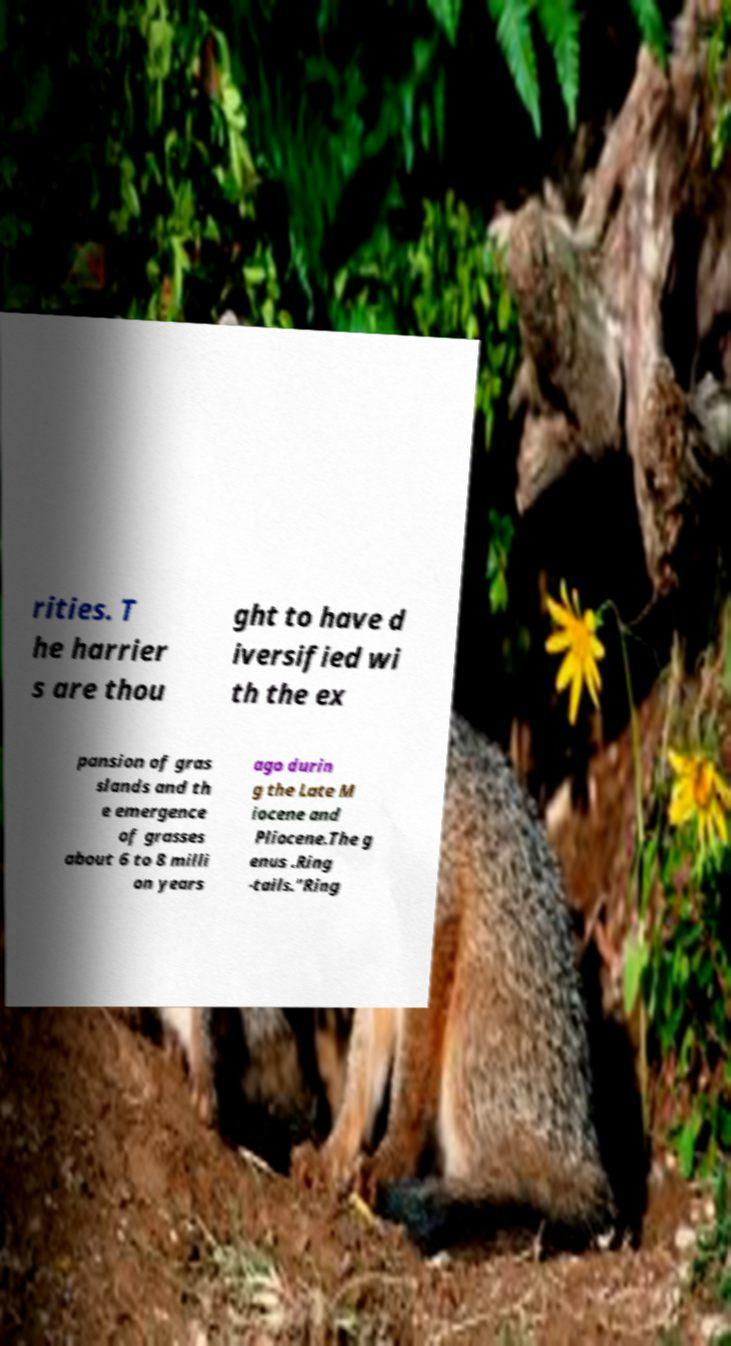There's text embedded in this image that I need extracted. Can you transcribe it verbatim? rities. T he harrier s are thou ght to have d iversified wi th the ex pansion of gras slands and th e emergence of grasses about 6 to 8 milli on years ago durin g the Late M iocene and Pliocene.The g enus .Ring -tails."Ring 